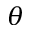Convert formula to latex. <formula><loc_0><loc_0><loc_500><loc_500>\theta</formula> 